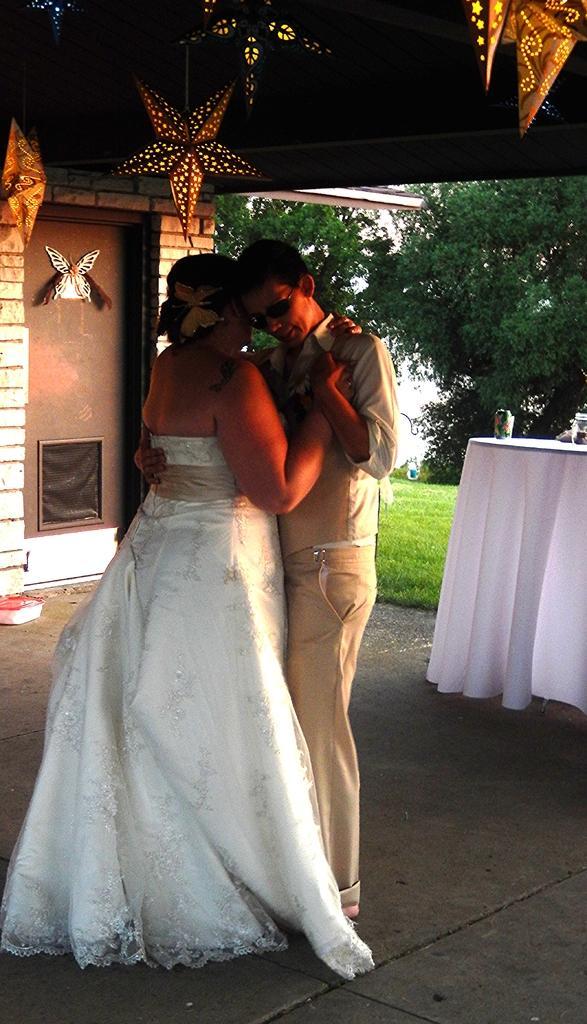How would you summarize this image in a sentence or two? In the image there is a couple standing in a dancing position and around them there are some decorations and behind them there is table covered with a white cloth and in the background there are some trees and some land is covered with grass. 